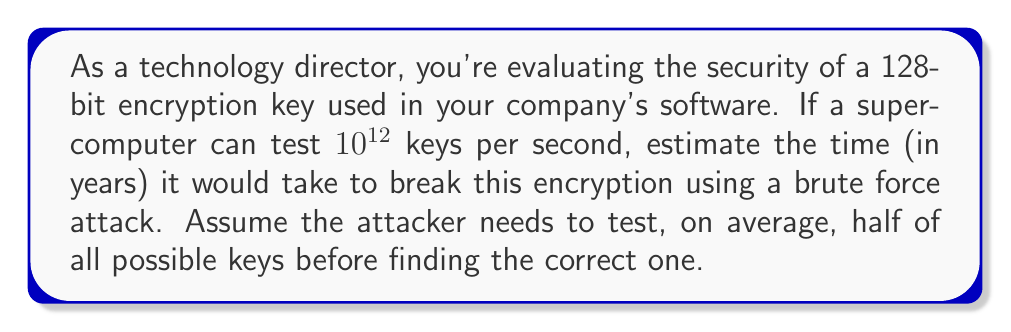Show me your answer to this math problem. Let's approach this step-by-step:

1) First, calculate the total number of possible 128-bit keys:
   $$2^{128} = 3.4028 \times 10^{38}$$

2) On average, the attacker needs to test half of these keys:
   $$\frac{3.4028 \times 10^{38}}{2} = 1.7014 \times 10^{38}$$

3) The supercomputer can test $10^{12}$ keys per second. To find the number of seconds needed:
   $$\frac{1.7014 \times 10^{38}}{10^{12}} = 1.7014 \times 10^{26} \text{ seconds}$$

4) Convert seconds to years:
   $$\frac{1.7014 \times 10^{26}}{60 \times 60 \times 24 \times 365.25} = 5.3917 \times 10^{18} \text{ years}$$

5) Round to a more manageable number:
   $$5.39 \times 10^{18} \text{ years}$$

This demonstrates the impracticality of brute-forcing a 128-bit encryption key, ensuring the security of your company's software updates and data.
Answer: $5.39 \times 10^{18}$ years 